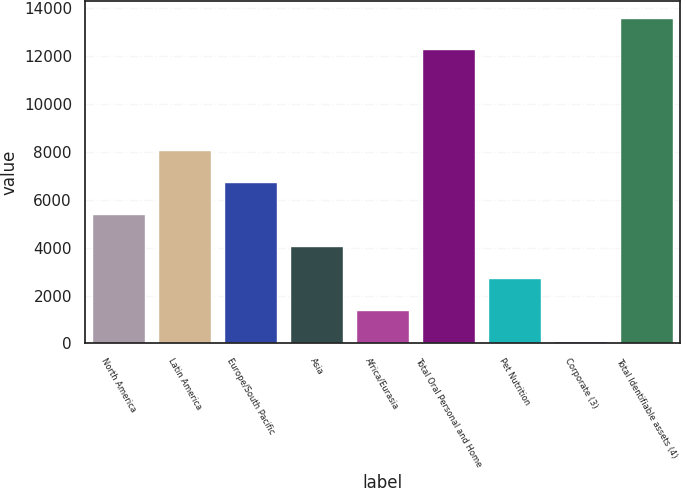Convert chart. <chart><loc_0><loc_0><loc_500><loc_500><bar_chart><fcel>North America<fcel>Latin America<fcel>Europe/South Pacific<fcel>Asia<fcel>Africa/Eurasia<fcel>Total Oral Personal and Home<fcel>Pet Nutrition<fcel>Corporate (3)<fcel>Total Identifiable assets (4)<nl><fcel>5409.2<fcel>8070.8<fcel>6740<fcel>4078.4<fcel>1416.8<fcel>12263<fcel>2747.6<fcel>86<fcel>13593.8<nl></chart> 